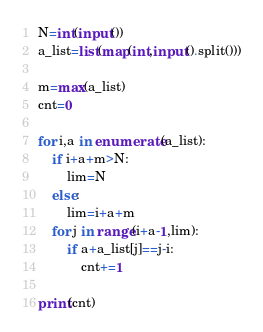<code> <loc_0><loc_0><loc_500><loc_500><_Python_>N=int(input())
a_list=list(map(int,input().split()))

m=max(a_list)
cnt=0

for i,a in enumerate(a_list):
    if i+a+m>N:
        lim=N
    else:
        lim=i+a+m
    for j in range(i+a-1,lim):
        if a+a_list[j]==j-i:
            cnt+=1

print(cnt)
</code> 